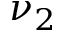Convert formula to latex. <formula><loc_0><loc_0><loc_500><loc_500>\nu _ { 2 }</formula> 